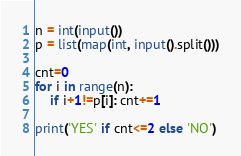Convert code to text. <code><loc_0><loc_0><loc_500><loc_500><_Python_>n = int(input())
p = list(map(int, input().split()))

cnt=0
for i in range(n):
    if i+1!=p[i]: cnt+=1
        
print('YES' if cnt<=2 else 'NO')</code> 